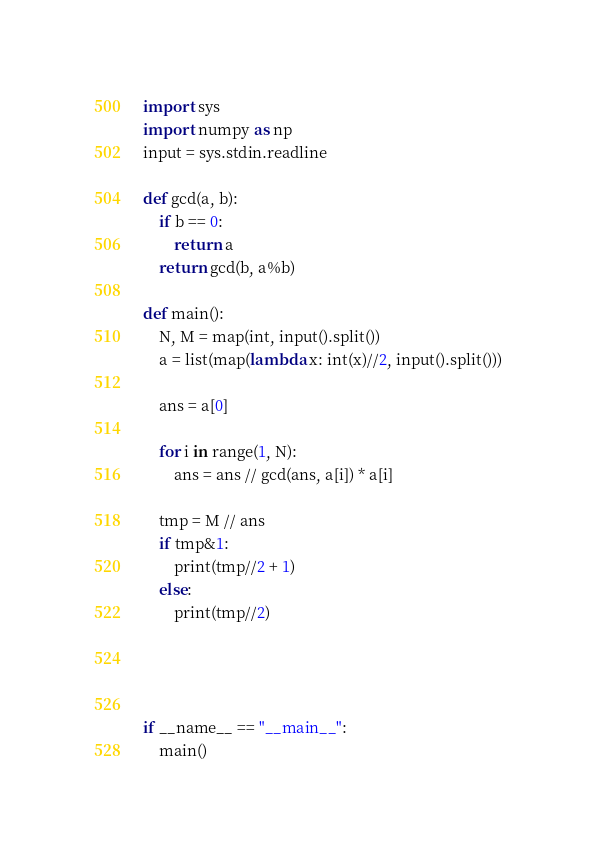Convert code to text. <code><loc_0><loc_0><loc_500><loc_500><_Python_>import sys
import numpy as np
input = sys.stdin.readline

def gcd(a, b):
    if b == 0:
        return a
    return gcd(b, a%b)

def main():
    N, M = map(int, input().split())
    a = list(map(lambda x: int(x)//2, input().split()))

    ans = a[0]

    for i in range(1, N):
        ans = ans // gcd(ans, a[i]) * a[i]
    
    tmp = M // ans
    if tmp&1:
        print(tmp//2 + 1)
    else:
        print(tmp//2)




if __name__ == "__main__":
    main()</code> 